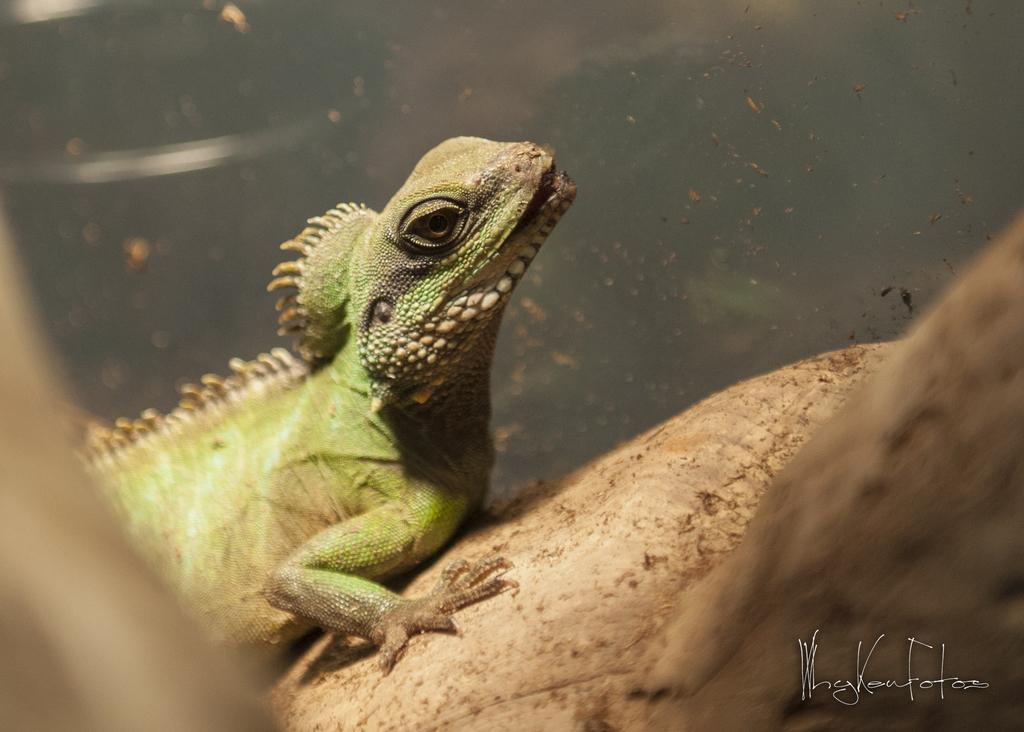What type of animal is in the image? There is a garden lizard in the image. What surface is the garden lizard on? The garden lizard is on wood. Is there any text present in the image? Yes, there is text visible at the bottom of the image. What type of soda is being poured onto the page in the image? There is no soda or page present in the image; it features a garden lizard on wood with text at the bottom. 